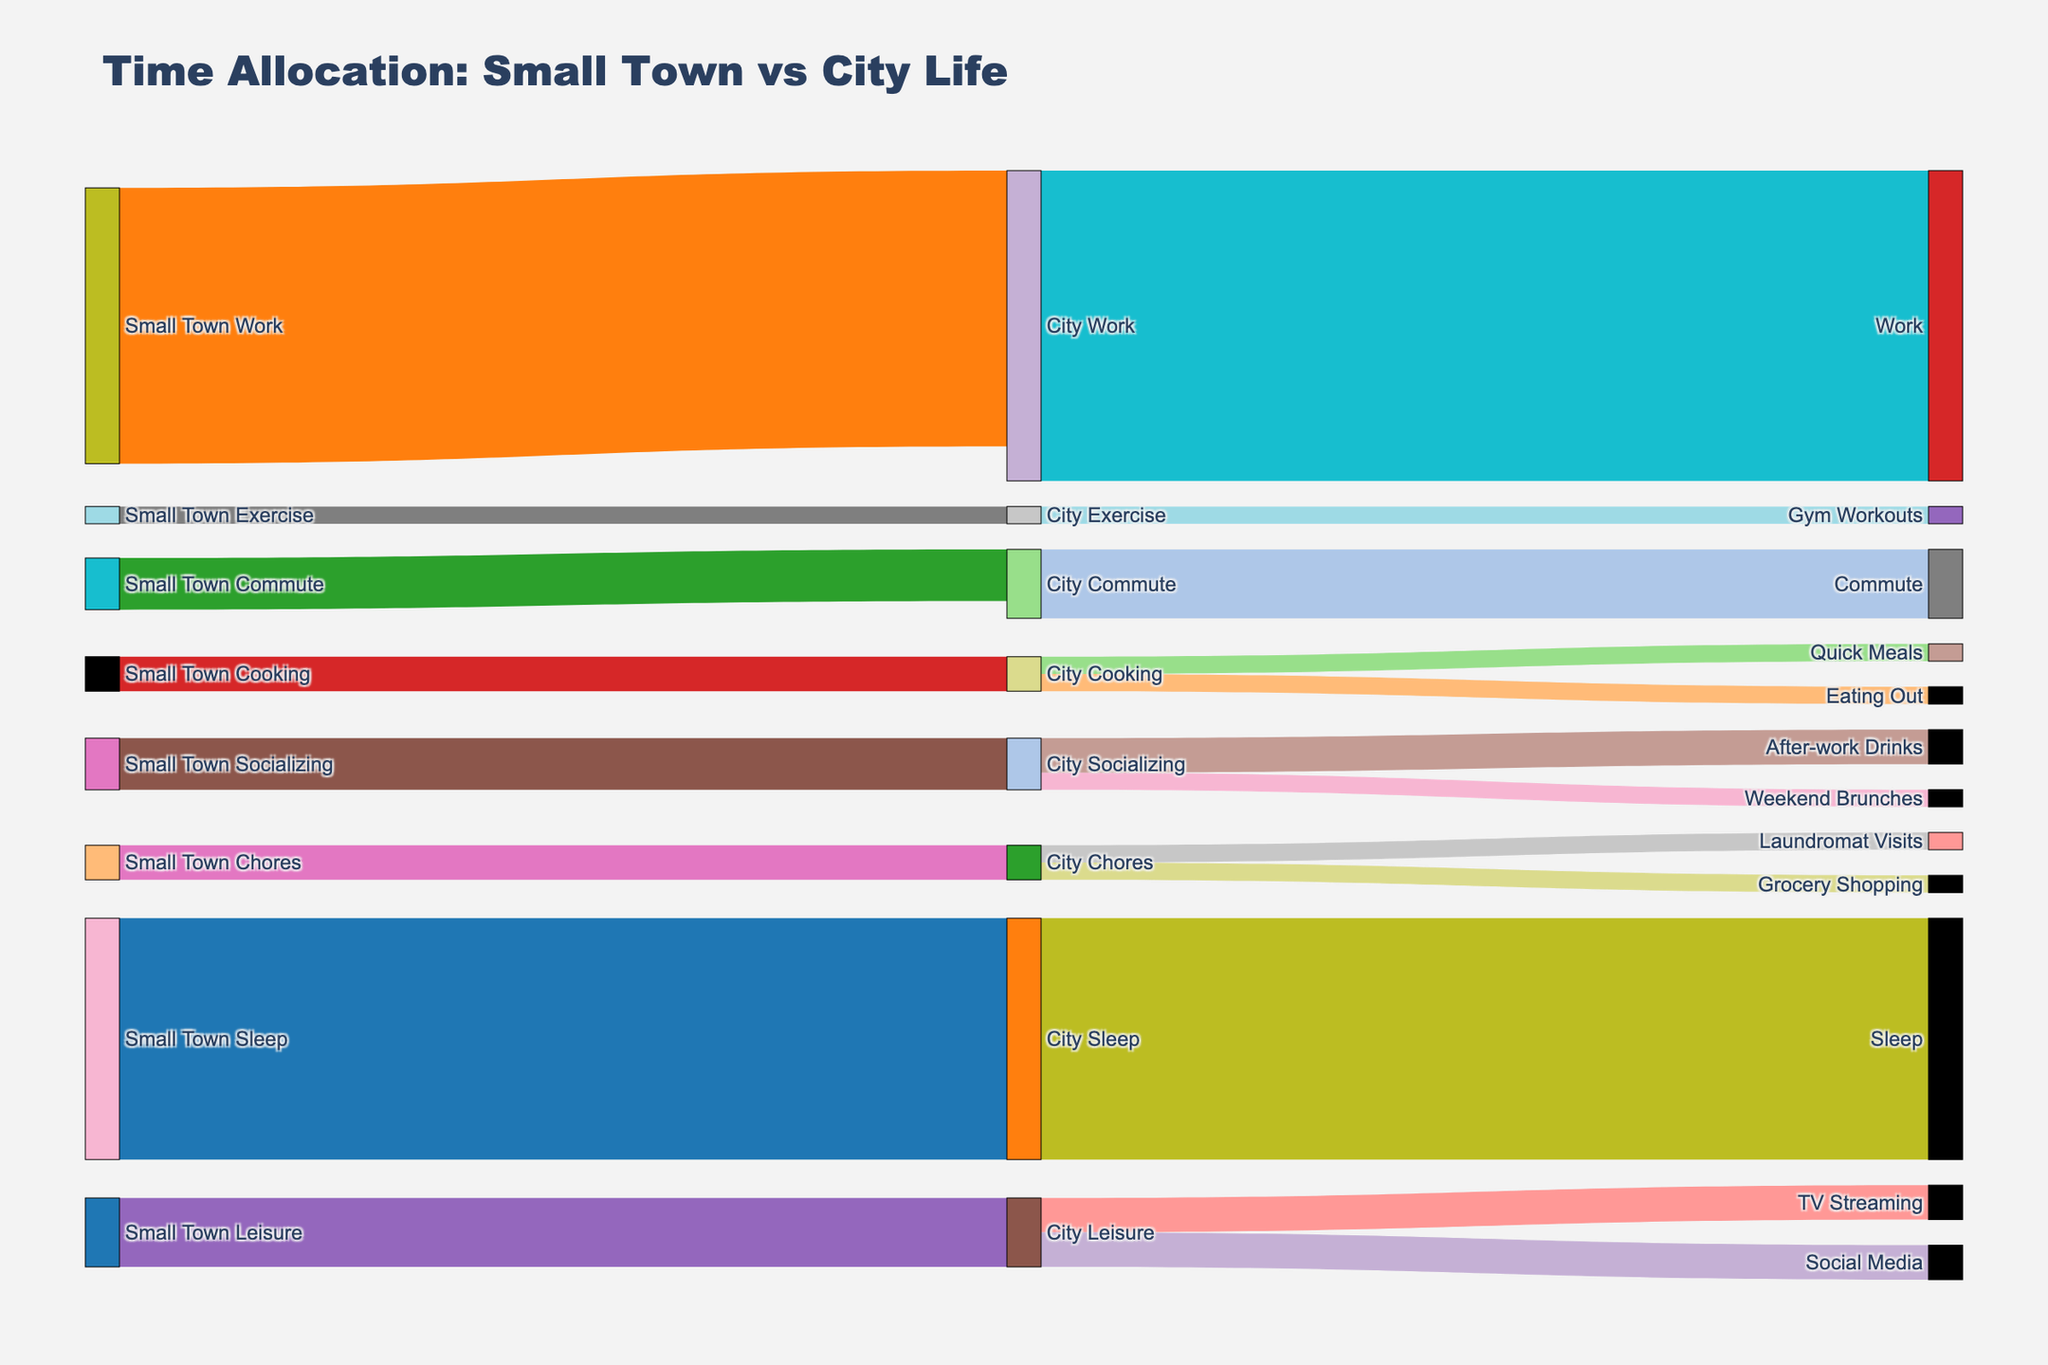what is the total time allocated to Work in the city? Add the time from 'City Work' source and target. The given data shows 8 hours for 'Small Town Work' becoming 9 hours in 'City Work'. Therefore, it's 9 hours.
Answer: 9 hours How much time do you save on Cooking after moving to the city? Compare the value for 'Small Town Cooking' with the combined values for 'Quick Meals' and 'Eating Out' in the city. 'Small Town Cooking' is 1 hour, while 'City Cooking' splits into 'Quick Meals' (0.5 hours) and 'Eating Out' (0.5 hours), totaling 1 hour. Thus, the time remains the same.
Answer: 0 hours What activity has the biggest increase in time expenditure after moving to the city? Subtract the time spent in the small town from the time spent in the city for each activity. 'Work' increased from 8 to 9 hours, 'Commute' increased from 1.5 to 2 hours, and 'After-work Drinks' is an entirely new category adding 1 hour. Therefore, 'Work' has the biggest increase by 1 hour.
Answer: Work Which leisure activity takes the most time in the city? Evaluate the leisure activities in the city. The data shows 1 hour each for 'TV Streaming' and 'Social Media'. Therefore, they are equal.
Answer: TV Streaming and Social Media Has the time allocated to Socializing increased or decreased? Compare time for 'Small Town Socializing' and 'City Socializing'. 'Small Town Socializing' is 1.5 hours, splitting into 'After-work Drinks' (1 hour) and 'Weekend Brunches' (0.5 hours), totaling to 1.5 hours. As the value remains the same, there is no change.
Answer: No change How much additional time do you spend on commuting in the city? Compare time values from 'Small Town Commute' (1.5 hours) and 'City Commute' (2 hours). The difference is 2 - 1.5 = 0.5 hours, meaning an additional 0.5 hours are spent.
Answer: 0.5 hours Which specific chore takes up the same amount of time in both places? Examine 'City Chores' split values and compare with 'Small Town Chores'. 'Small Town Chores' is 1 hour, divided into 'Laundromat Visits' and 'Grocery Shopping' (both 0.5 hours each). Individually they differ, but collectively the time remains same. Hence, no individual chore matches perfectly.
Answer: None 